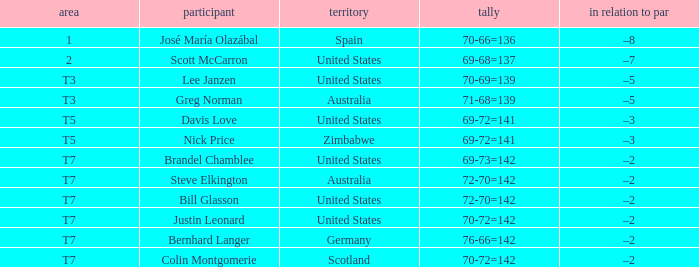Who is the Player with a Score of 70-72=142? Question 3 Justin Leonard, Colin Montgomerie. 